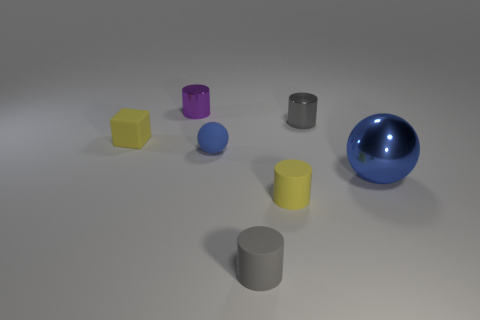The rubber ball that is left of the small gray thing that is behind the gray matte cylinder is what color?
Ensure brevity in your answer.  Blue. There is a yellow matte thing in front of the object on the left side of the tiny purple thing that is behind the tiny blue thing; what size is it?
Offer a terse response. Small. Does the large blue object have the same material as the blue ball on the left side of the large shiny thing?
Your response must be concise. No. What size is the sphere that is made of the same material as the tiny purple thing?
Offer a very short reply. Large. Are there any gray shiny objects of the same shape as the purple metallic thing?
Your answer should be compact. Yes. How many objects are either small yellow objects that are on the right side of the tiny blue matte object or matte spheres?
Ensure brevity in your answer.  2. There is a thing that is the same color as the block; what is its size?
Give a very brief answer. Small. Does the ball left of the blue metallic object have the same color as the small metallic cylinder that is right of the blue matte sphere?
Ensure brevity in your answer.  No. How big is the yellow cube?
Provide a short and direct response. Small. How many large things are blue rubber spheres or yellow objects?
Offer a terse response. 0. 